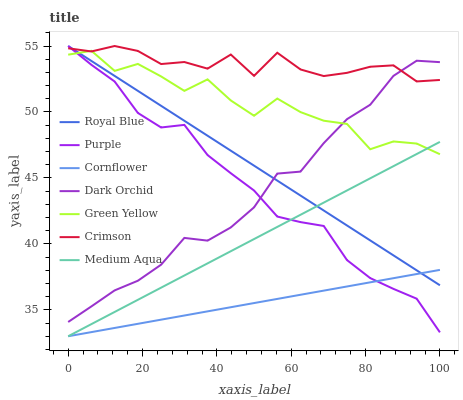Does Cornflower have the minimum area under the curve?
Answer yes or no. Yes. Does Crimson have the maximum area under the curve?
Answer yes or no. Yes. Does Purple have the minimum area under the curve?
Answer yes or no. No. Does Purple have the maximum area under the curve?
Answer yes or no. No. Is Royal Blue the smoothest?
Answer yes or no. Yes. Is Green Yellow the roughest?
Answer yes or no. Yes. Is Purple the smoothest?
Answer yes or no. No. Is Purple the roughest?
Answer yes or no. No. Does Cornflower have the lowest value?
Answer yes or no. Yes. Does Purple have the lowest value?
Answer yes or no. No. Does Crimson have the highest value?
Answer yes or no. Yes. Does Dark Orchid have the highest value?
Answer yes or no. No. Is Medium Aqua less than Crimson?
Answer yes or no. Yes. Is Crimson greater than Medium Aqua?
Answer yes or no. Yes. Does Royal Blue intersect Green Yellow?
Answer yes or no. Yes. Is Royal Blue less than Green Yellow?
Answer yes or no. No. Is Royal Blue greater than Green Yellow?
Answer yes or no. No. Does Medium Aqua intersect Crimson?
Answer yes or no. No. 